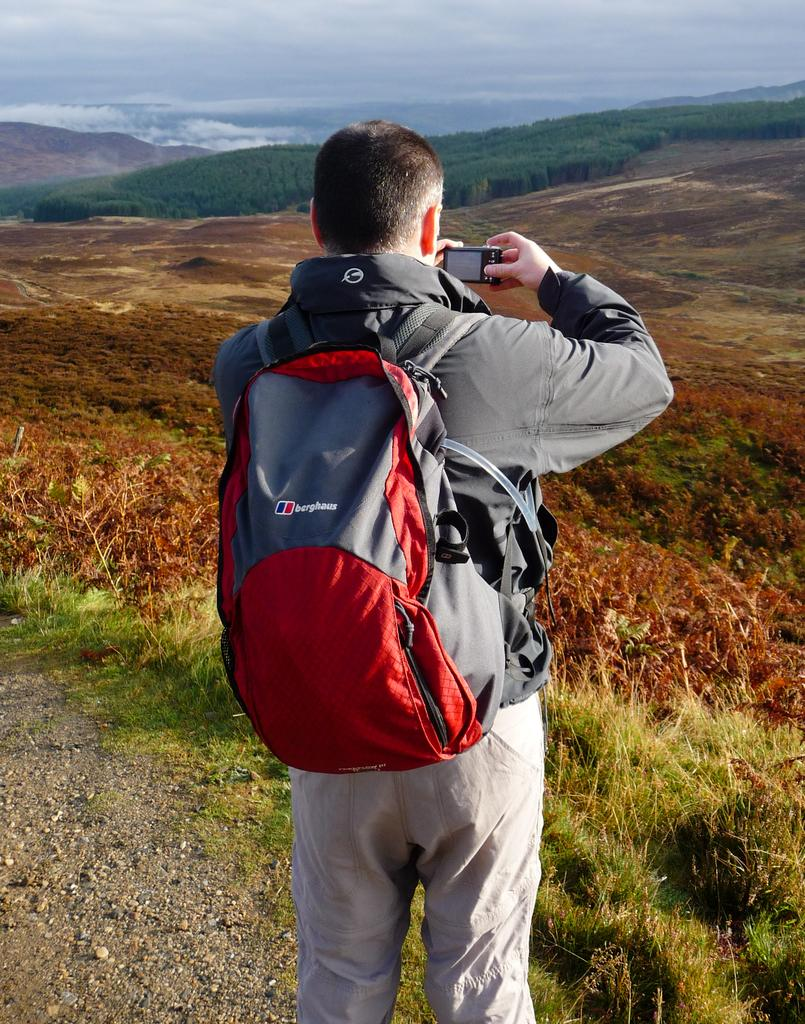<image>
Relay a brief, clear account of the picture shown. Man wearing an orange berghaus backpack taking a photo. 